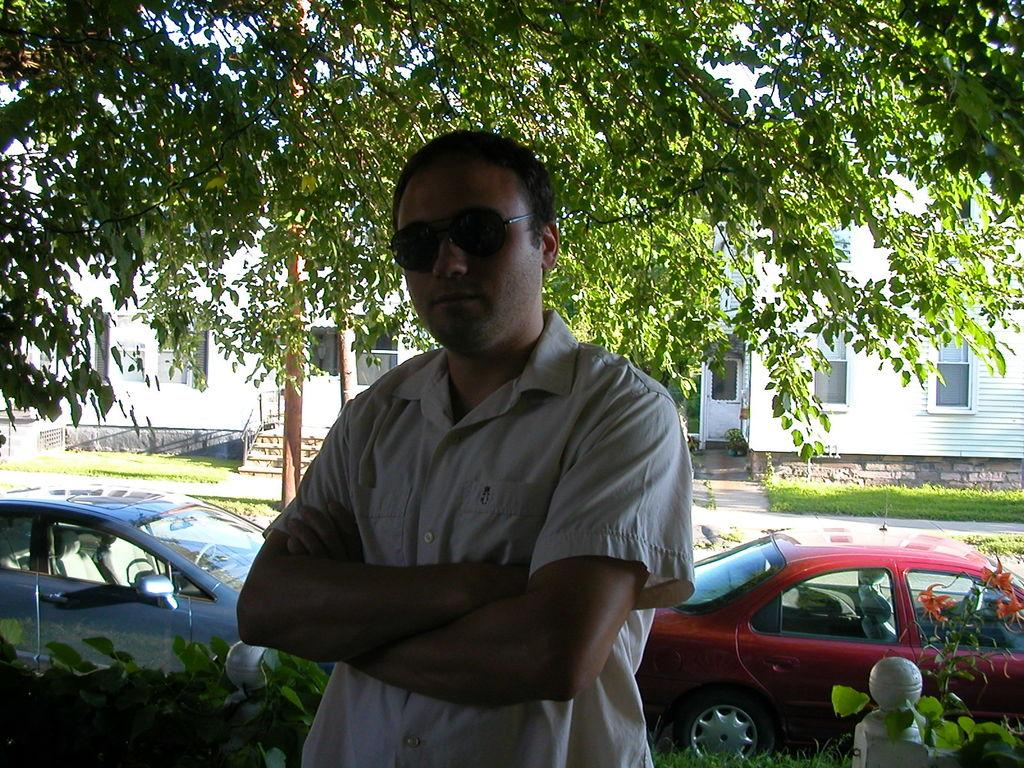What is the person in the image wearing on their face? The person in the image is wearing goggles. What type of natural elements can be seen in the image? There are plants and trees visible in the image. What can be seen in the background of the image? There are two cars and buildings in the background of the image. What type of silk is draped over the arch in the image? There is no silk or arch present in the image. What type of board game is being played by the person in the image? There is no board game visible in the image; the person is wearing goggles. 